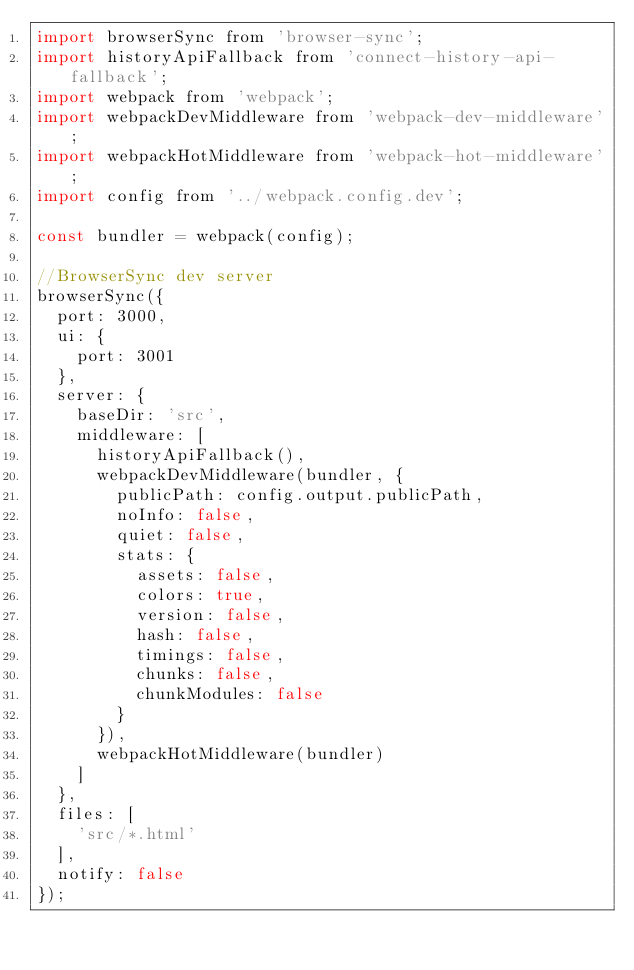Convert code to text. <code><loc_0><loc_0><loc_500><loc_500><_JavaScript_>import browserSync from 'browser-sync';
import historyApiFallback from 'connect-history-api-fallback';
import webpack from 'webpack';
import webpackDevMiddleware from 'webpack-dev-middleware';
import webpackHotMiddleware from 'webpack-hot-middleware';
import config from '../webpack.config.dev';

const bundler = webpack(config);

//BrowserSync dev server
browserSync({
  port: 3000,
  ui: {
    port: 3001
  },
  server: {
    baseDir: 'src',
    middleware: [
      historyApiFallback(),
      webpackDevMiddleware(bundler, {
        publicPath: config.output.publicPath,
        noInfo: false,
        quiet: false,
        stats: {
          assets: false,
          colors: true,
          version: false,
          hash: false,
          timings: false,
          chunks: false,
          chunkModules: false
        }
      }),
      webpackHotMiddleware(bundler)
    ]
  },
  files: [
    'src/*.html'
  ],
  notify: false
});
</code> 